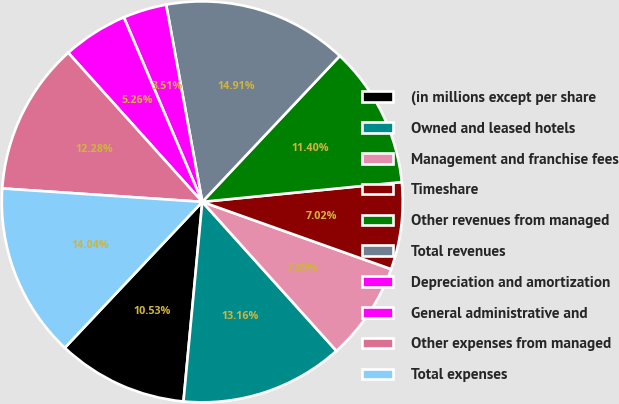Convert chart. <chart><loc_0><loc_0><loc_500><loc_500><pie_chart><fcel>(in millions except per share<fcel>Owned and leased hotels<fcel>Management and franchise fees<fcel>Timeshare<fcel>Other revenues from managed<fcel>Total revenues<fcel>Depreciation and amortization<fcel>General administrative and<fcel>Other expenses from managed<fcel>Total expenses<nl><fcel>10.53%<fcel>13.16%<fcel>7.89%<fcel>7.02%<fcel>11.4%<fcel>14.91%<fcel>3.51%<fcel>5.26%<fcel>12.28%<fcel>14.04%<nl></chart> 